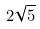Convert formula to latex. <formula><loc_0><loc_0><loc_500><loc_500>2 \sqrt { 5 }</formula> 